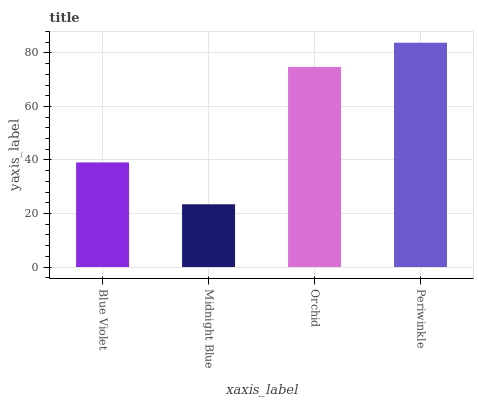Is Midnight Blue the minimum?
Answer yes or no. Yes. Is Periwinkle the maximum?
Answer yes or no. Yes. Is Orchid the minimum?
Answer yes or no. No. Is Orchid the maximum?
Answer yes or no. No. Is Orchid greater than Midnight Blue?
Answer yes or no. Yes. Is Midnight Blue less than Orchid?
Answer yes or no. Yes. Is Midnight Blue greater than Orchid?
Answer yes or no. No. Is Orchid less than Midnight Blue?
Answer yes or no. No. Is Orchid the high median?
Answer yes or no. Yes. Is Blue Violet the low median?
Answer yes or no. Yes. Is Blue Violet the high median?
Answer yes or no. No. Is Periwinkle the low median?
Answer yes or no. No. 